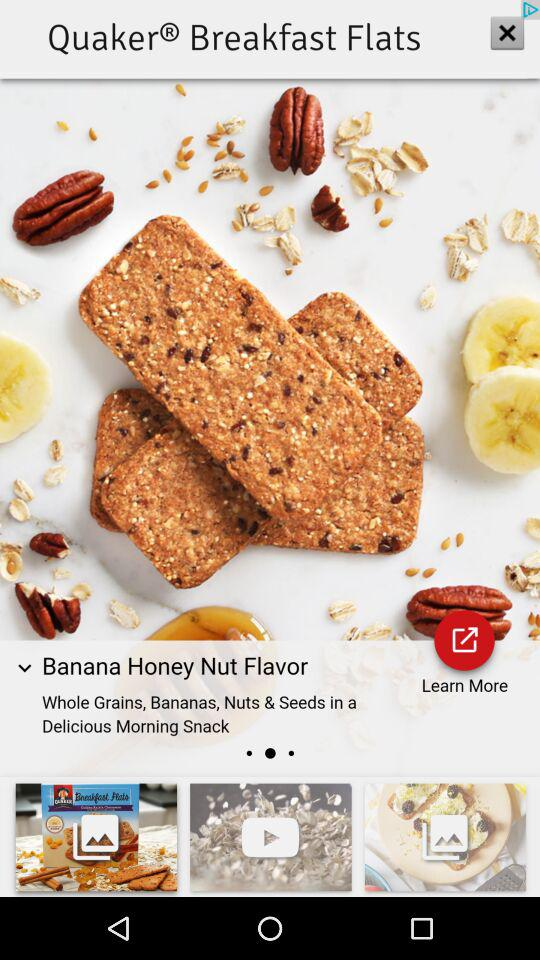What is the dish name? The dish name is Banana Honey Nut Flavor. 